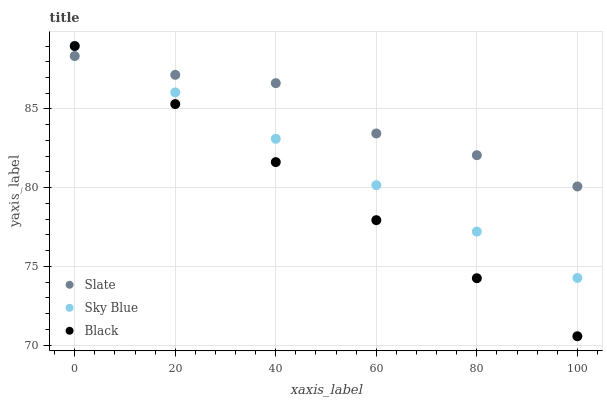Does Black have the minimum area under the curve?
Answer yes or no. Yes. Does Slate have the maximum area under the curve?
Answer yes or no. Yes. Does Slate have the minimum area under the curve?
Answer yes or no. No. Does Black have the maximum area under the curve?
Answer yes or no. No. Is Sky Blue the smoothest?
Answer yes or no. Yes. Is Slate the roughest?
Answer yes or no. Yes. Is Black the smoothest?
Answer yes or no. No. Is Black the roughest?
Answer yes or no. No. Does Black have the lowest value?
Answer yes or no. Yes. Does Slate have the lowest value?
Answer yes or no. No. Does Black have the highest value?
Answer yes or no. Yes. Does Slate have the highest value?
Answer yes or no. No. Does Sky Blue intersect Black?
Answer yes or no. Yes. Is Sky Blue less than Black?
Answer yes or no. No. Is Sky Blue greater than Black?
Answer yes or no. No. 